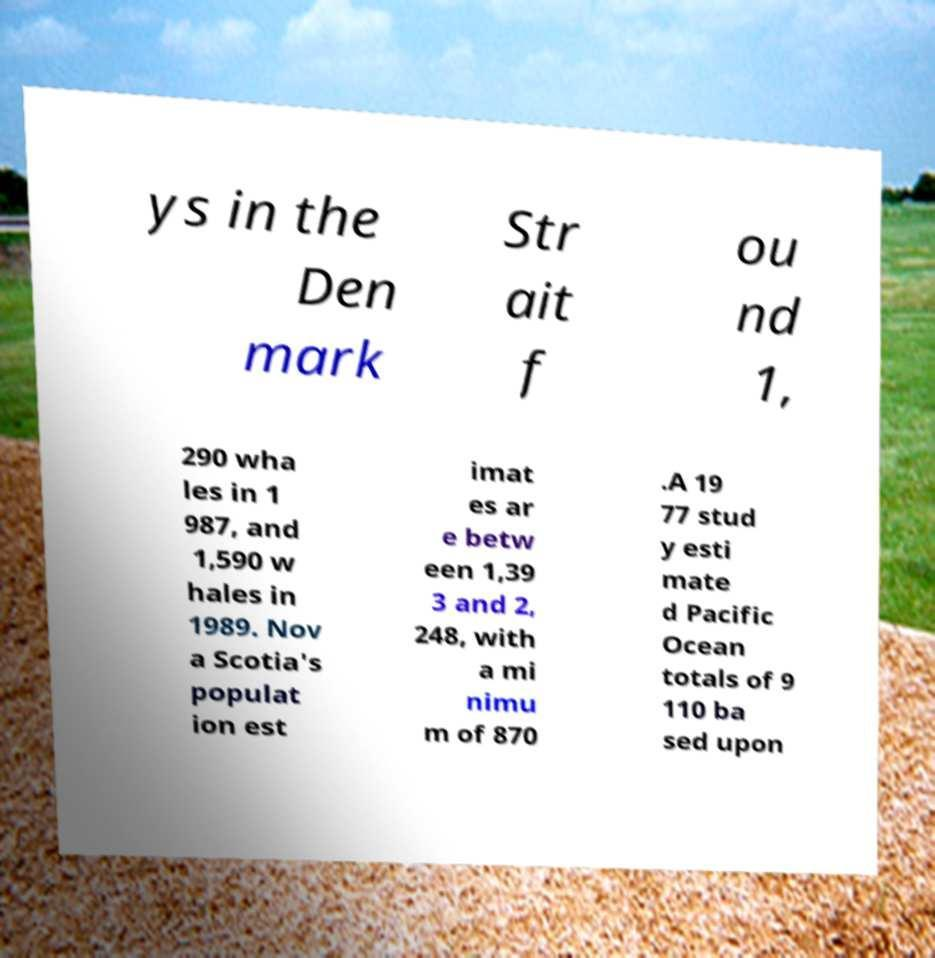For documentation purposes, I need the text within this image transcribed. Could you provide that? ys in the Den mark Str ait f ou nd 1, 290 wha les in 1 987, and 1,590 w hales in 1989. Nov a Scotia's populat ion est imat es ar e betw een 1,39 3 and 2, 248, with a mi nimu m of 870 .A 19 77 stud y esti mate d Pacific Ocean totals of 9 110 ba sed upon 